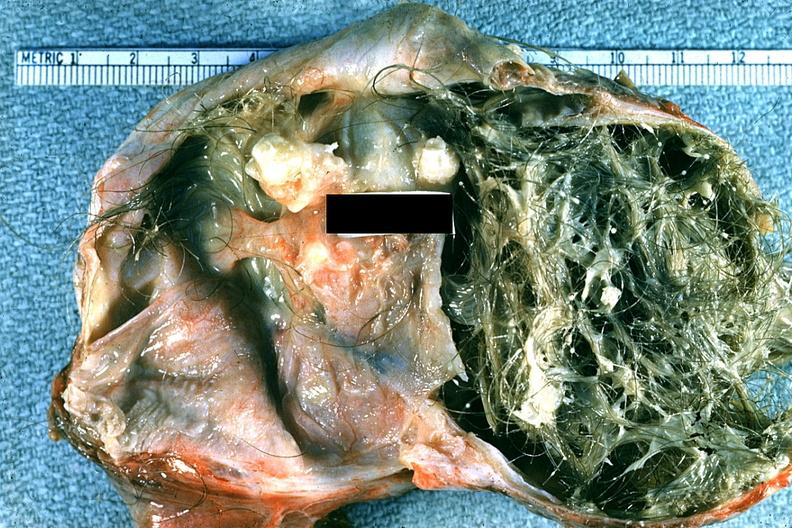does chest and abdomen slide show good example typical dermoid with hair and sebaceous material?
Answer the question using a single word or phrase. No 